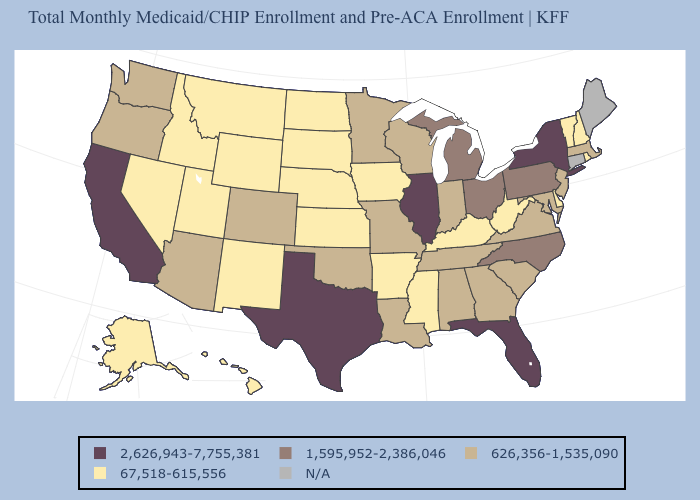What is the highest value in states that border New Jersey?
Answer briefly. 2,626,943-7,755,381. How many symbols are there in the legend?
Short answer required. 5. What is the value of South Carolina?
Quick response, please. 626,356-1,535,090. Does Texas have the lowest value in the South?
Be succinct. No. What is the value of Pennsylvania?
Give a very brief answer. 1,595,952-2,386,046. Does Idaho have the lowest value in the USA?
Be succinct. Yes. What is the lowest value in the West?
Concise answer only. 67,518-615,556. Name the states that have a value in the range 2,626,943-7,755,381?
Concise answer only. California, Florida, Illinois, New York, Texas. Which states hav the highest value in the West?
Short answer required. California. Among the states that border Minnesota , does Wisconsin have the highest value?
Concise answer only. Yes. Which states have the lowest value in the South?
Short answer required. Arkansas, Delaware, Kentucky, Mississippi, West Virginia. What is the highest value in the USA?
Quick response, please. 2,626,943-7,755,381. What is the value of California?
Keep it brief. 2,626,943-7,755,381. Name the states that have a value in the range 67,518-615,556?
Answer briefly. Alaska, Arkansas, Delaware, Hawaii, Idaho, Iowa, Kansas, Kentucky, Mississippi, Montana, Nebraska, Nevada, New Hampshire, New Mexico, North Dakota, Rhode Island, South Dakota, Utah, Vermont, West Virginia, Wyoming. What is the value of Illinois?
Short answer required. 2,626,943-7,755,381. 